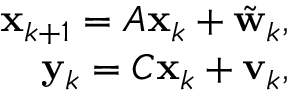<formula> <loc_0><loc_0><loc_500><loc_500>\begin{array} { r } { x _ { k + 1 } = A x _ { k } + \tilde { w } _ { k } , } \\ { y _ { k } = C x _ { k } + v _ { k } , } \end{array}</formula> 